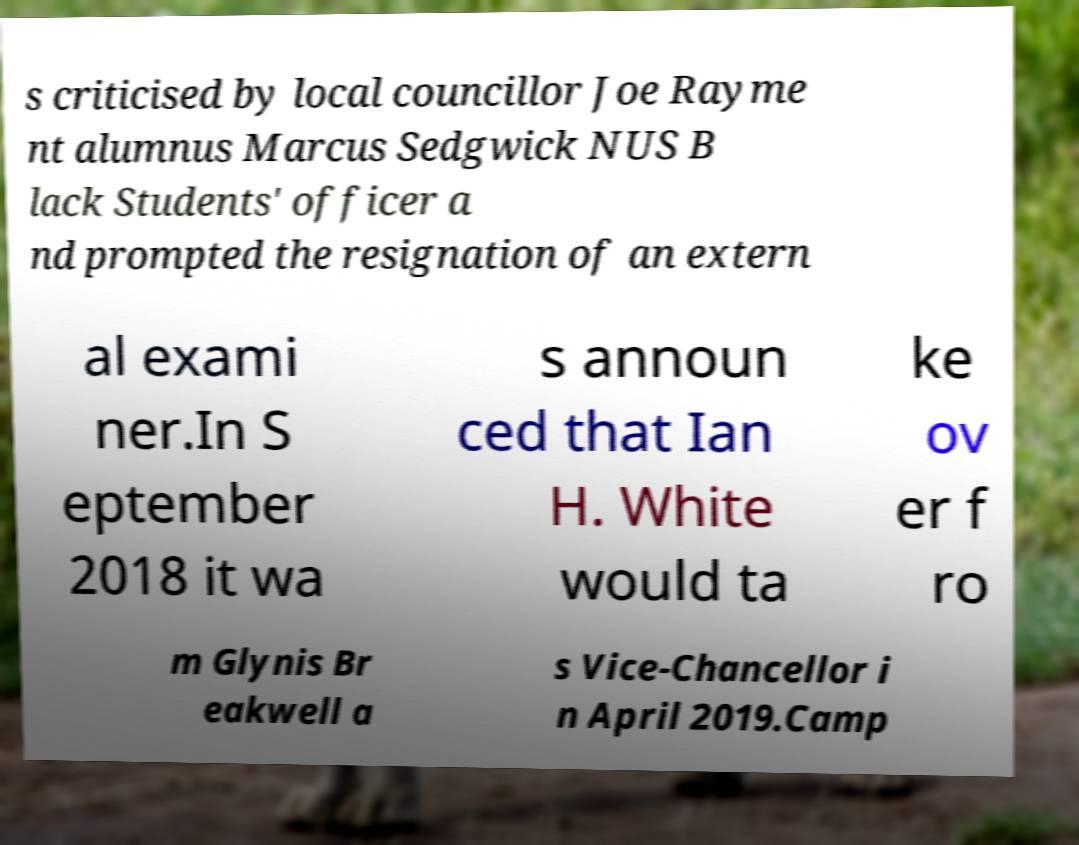I need the written content from this picture converted into text. Can you do that? s criticised by local councillor Joe Rayme nt alumnus Marcus Sedgwick NUS B lack Students' officer a nd prompted the resignation of an extern al exami ner.In S eptember 2018 it wa s announ ced that Ian H. White would ta ke ov er f ro m Glynis Br eakwell a s Vice-Chancellor i n April 2019.Camp 